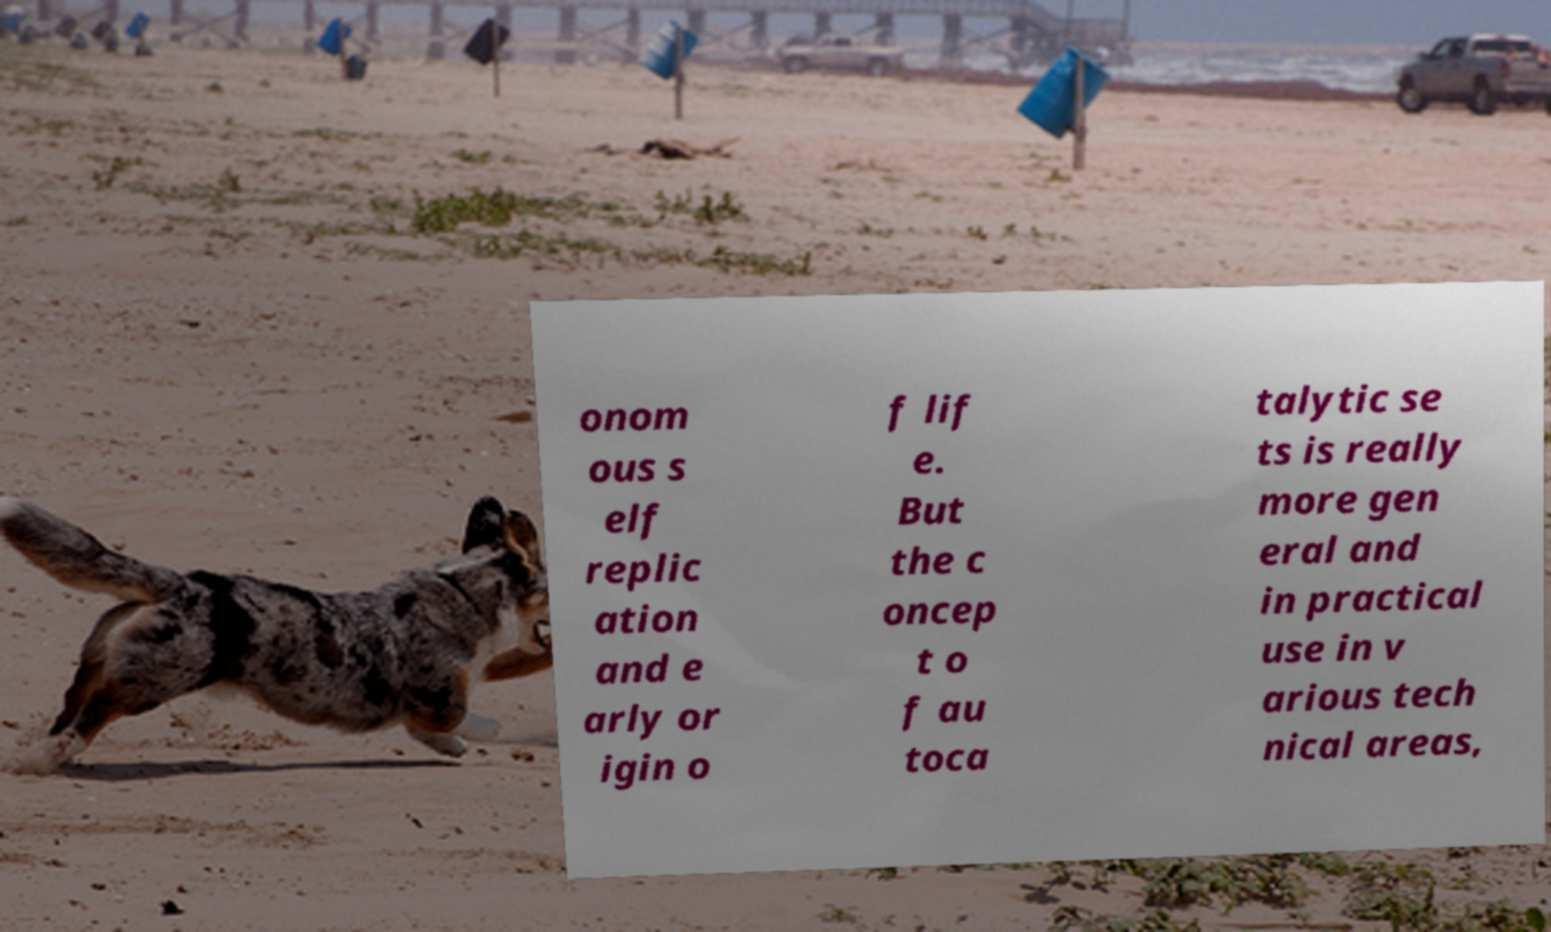For documentation purposes, I need the text within this image transcribed. Could you provide that? onom ous s elf replic ation and e arly or igin o f lif e. But the c oncep t o f au toca talytic se ts is really more gen eral and in practical use in v arious tech nical areas, 